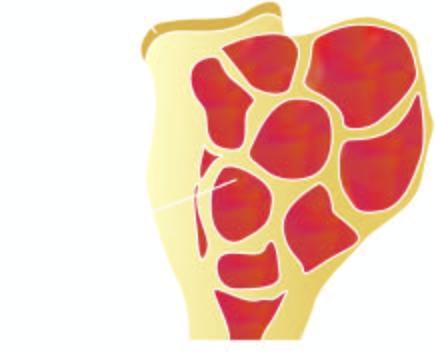where is the end of the long bone expanded?
Answer the question using a single word or phrase. In region of epiphysis 